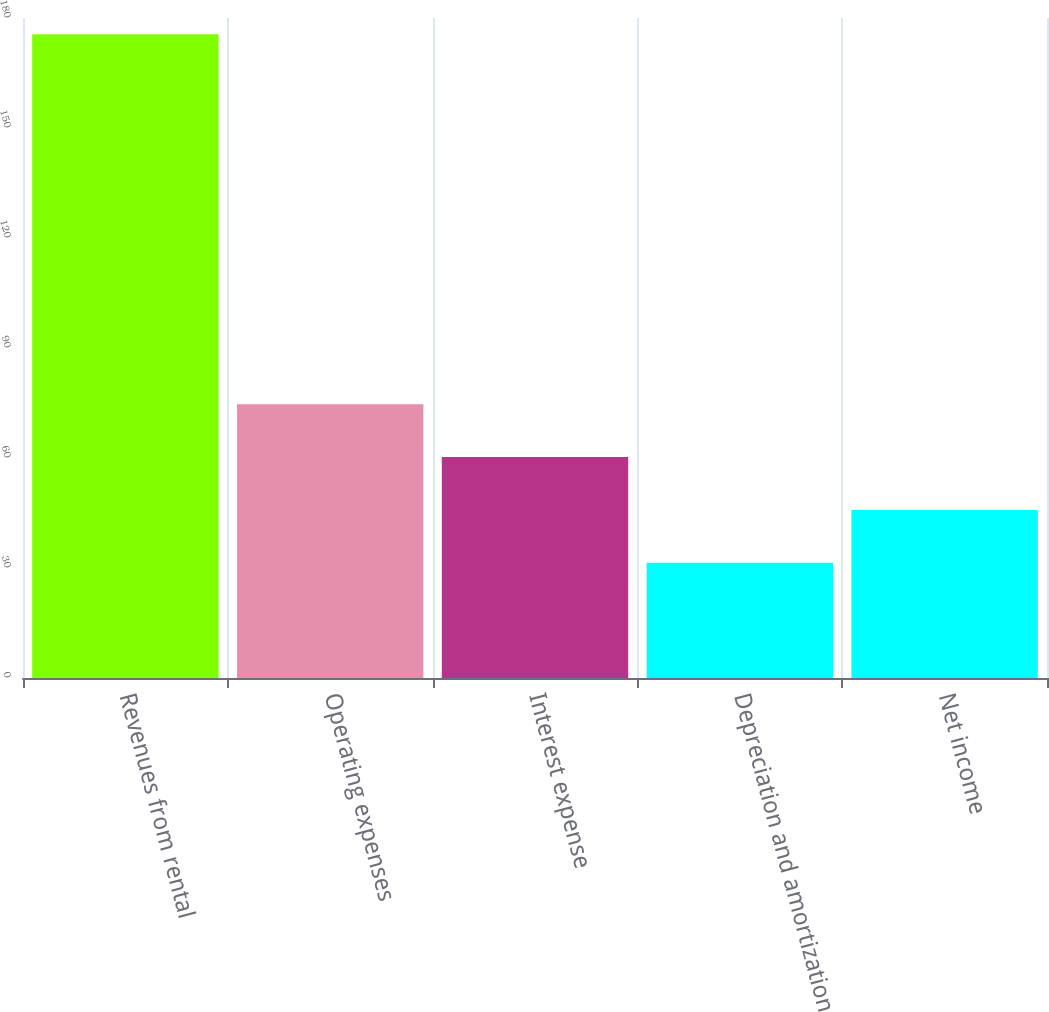<chart> <loc_0><loc_0><loc_500><loc_500><bar_chart><fcel>Revenues from rental<fcel>Operating expenses<fcel>Interest expense<fcel>Depreciation and amortization<fcel>Net income<nl><fcel>175.6<fcel>74.66<fcel>60.24<fcel>31.4<fcel>45.82<nl></chart> 